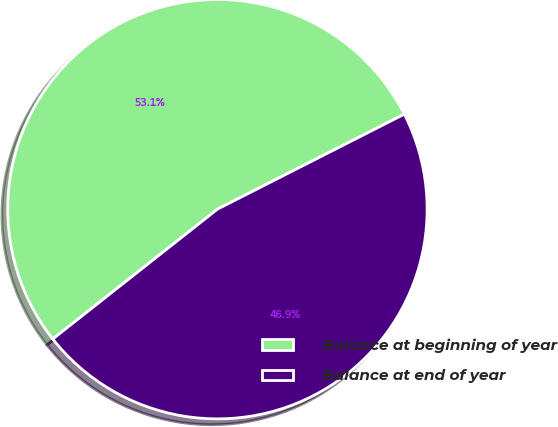Convert chart to OTSL. <chart><loc_0><loc_0><loc_500><loc_500><pie_chart><fcel>Balance at beginning of year<fcel>Balance at end of year<nl><fcel>53.14%<fcel>46.86%<nl></chart> 